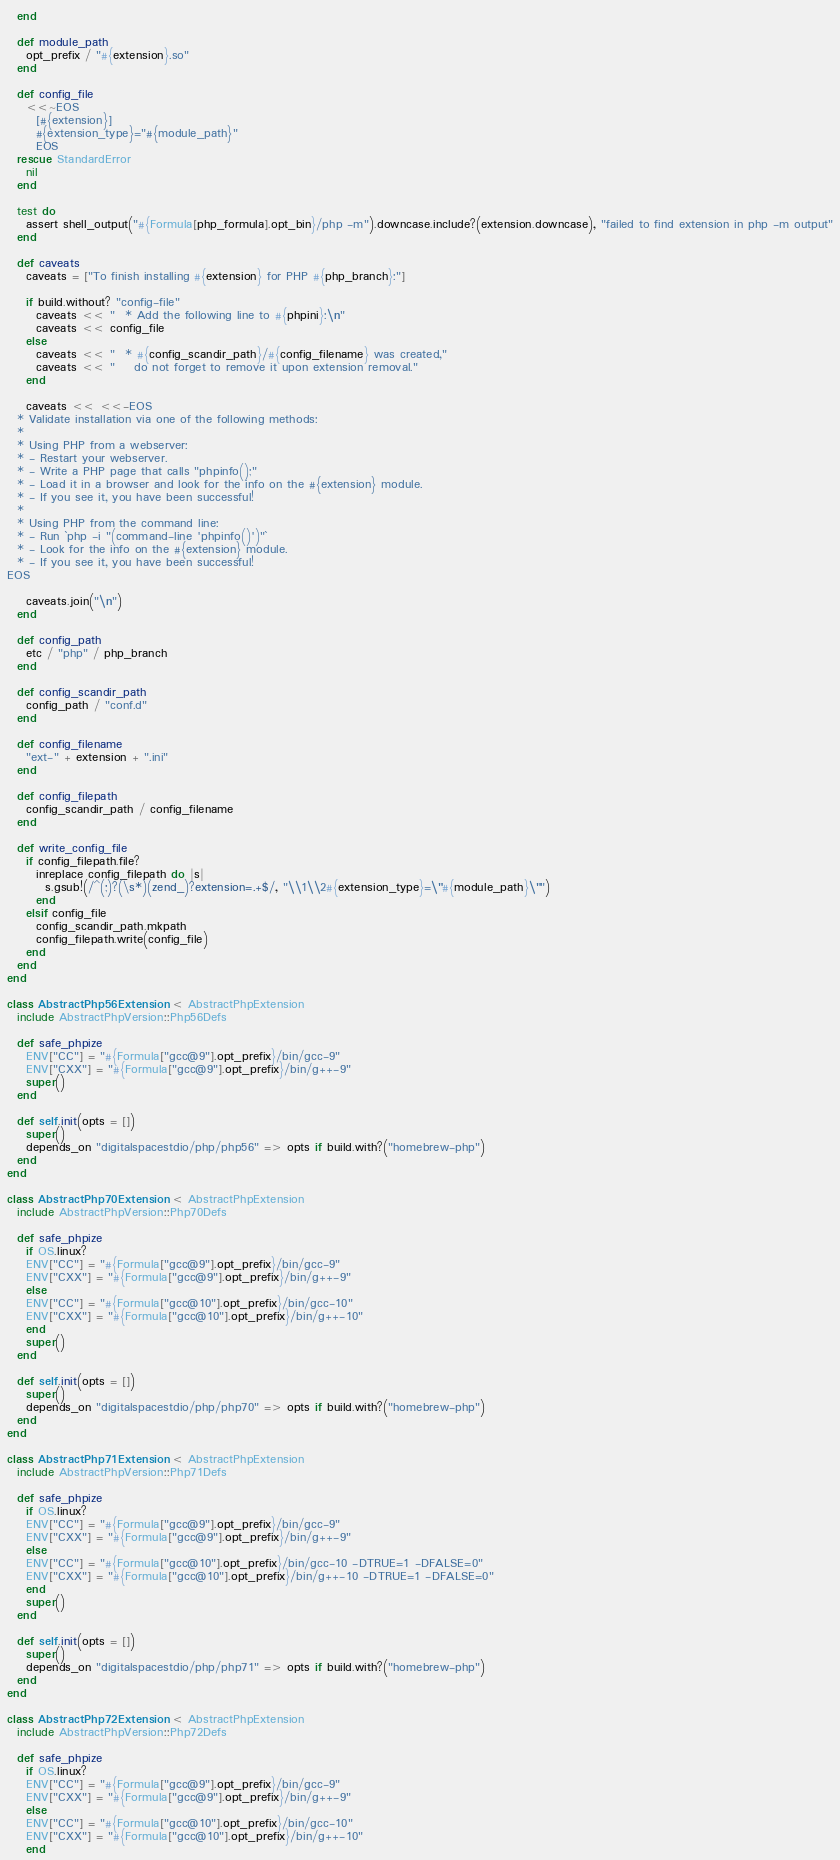<code> <loc_0><loc_0><loc_500><loc_500><_Ruby_>  end

  def module_path
    opt_prefix / "#{extension}.so"
  end

  def config_file
    <<~EOS
      [#{extension}]
      #{extension_type}="#{module_path}"
      EOS
  rescue StandardError
    nil
  end

  test do
    assert shell_output("#{Formula[php_formula].opt_bin}/php -m").downcase.include?(extension.downcase), "failed to find extension in php -m output"
  end

  def caveats
    caveats = ["To finish installing #{extension} for PHP #{php_branch}:"]

    if build.without? "config-file"
      caveats << "  * Add the following line to #{phpini}:\n"
      caveats << config_file
    else
      caveats << "  * #{config_scandir_path}/#{config_filename} was created,"
      caveats << "    do not forget to remove it upon extension removal."
    end

    caveats << <<-EOS
  * Validate installation via one of the following methods:
  *
  * Using PHP from a webserver:
  * - Restart your webserver.
  * - Write a PHP page that calls "phpinfo();"
  * - Load it in a browser and look for the info on the #{extension} module.
  * - If you see it, you have been successful!
  *
  * Using PHP from the command line:
  * - Run `php -i "(command-line 'phpinfo()')"`
  * - Look for the info on the #{extension} module.
  * - If you see it, you have been successful!
EOS

    caveats.join("\n")
  end

  def config_path
    etc / "php" / php_branch
  end

  def config_scandir_path
    config_path / "conf.d"
  end

  def config_filename
    "ext-" + extension + ".ini"
  end

  def config_filepath
    config_scandir_path / config_filename
  end

  def write_config_file
    if config_filepath.file?
      inreplace config_filepath do |s|
        s.gsub!(/^(;)?(\s*)(zend_)?extension=.+$/, "\\1\\2#{extension_type}=\"#{module_path}\"")
      end
    elsif config_file
      config_scandir_path.mkpath
      config_filepath.write(config_file)
    end
  end
end

class AbstractPhp56Extension < AbstractPhpExtension
  include AbstractPhpVersion::Php56Defs

  def safe_phpize
    ENV["CC"] = "#{Formula["gcc@9"].opt_prefix}/bin/gcc-9"
    ENV["CXX"] = "#{Formula["gcc@9"].opt_prefix}/bin/g++-9"
    super()
  end

  def self.init(opts = [])
    super()
    depends_on "digitalspacestdio/php/php56" => opts if build.with?("homebrew-php")
  end
end

class AbstractPhp70Extension < AbstractPhpExtension
  include AbstractPhpVersion::Php70Defs

  def safe_phpize
    if OS.linux?
    ENV["CC"] = "#{Formula["gcc@9"].opt_prefix}/bin/gcc-9"
    ENV["CXX"] = "#{Formula["gcc@9"].opt_prefix}/bin/g++-9"
    else
    ENV["CC"] = "#{Formula["gcc@10"].opt_prefix}/bin/gcc-10"
    ENV["CXX"] = "#{Formula["gcc@10"].opt_prefix}/bin/g++-10"
    end
    super()
  end

  def self.init(opts = [])
    super()
    depends_on "digitalspacestdio/php/php70" => opts if build.with?("homebrew-php")
  end
end

class AbstractPhp71Extension < AbstractPhpExtension
  include AbstractPhpVersion::Php71Defs

  def safe_phpize
    if OS.linux?
    ENV["CC"] = "#{Formula["gcc@9"].opt_prefix}/bin/gcc-9"
    ENV["CXX"] = "#{Formula["gcc@9"].opt_prefix}/bin/g++-9"
    else
    ENV["CC"] = "#{Formula["gcc@10"].opt_prefix}/bin/gcc-10 -DTRUE=1 -DFALSE=0"
    ENV["CXX"] = "#{Formula["gcc@10"].opt_prefix}/bin/g++-10 -DTRUE=1 -DFALSE=0"
    end
    super()
  end

  def self.init(opts = [])
    super()
    depends_on "digitalspacestdio/php/php71" => opts if build.with?("homebrew-php")
  end
end

class AbstractPhp72Extension < AbstractPhpExtension
  include AbstractPhpVersion::Php72Defs

  def safe_phpize
    if OS.linux?
    ENV["CC"] = "#{Formula["gcc@9"].opt_prefix}/bin/gcc-9"
    ENV["CXX"] = "#{Formula["gcc@9"].opt_prefix}/bin/g++-9"
    else
    ENV["CC"] = "#{Formula["gcc@10"].opt_prefix}/bin/gcc-10"
    ENV["CXX"] = "#{Formula["gcc@10"].opt_prefix}/bin/g++-10"
    end</code> 